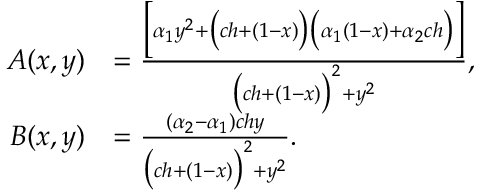Convert formula to latex. <formula><loc_0><loc_0><loc_500><loc_500>\begin{array} { r l } { A ( x , y ) } & { = \frac { \left [ \alpha _ { 1 } y ^ { 2 } + \left ( c h + ( 1 - x ) \right ) \left ( \alpha _ { 1 } ( 1 - x ) + \alpha _ { 2 } c h \right ) \right ] } { \left ( c h + ( 1 - x ) \right ) ^ { 2 } + y ^ { 2 } } , } \\ { B ( x , y ) } & { = \frac { ( \alpha _ { 2 } - \alpha _ { 1 } ) c h y } { \left ( c h + ( 1 - x ) \right ) ^ { 2 } + y ^ { 2 } } . } \end{array}</formula> 